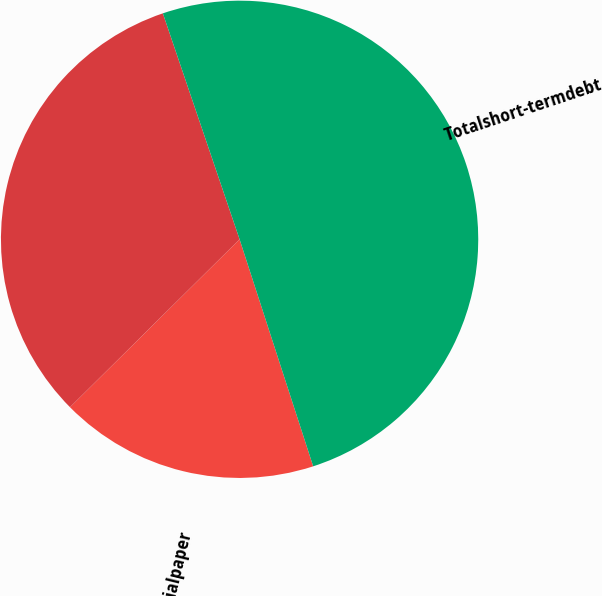<chart> <loc_0><loc_0><loc_500><loc_500><pie_chart><fcel>Commercialpaper<fcel>Unnamed: 1<fcel>Totalshort-termdebt<nl><fcel>17.57%<fcel>32.21%<fcel>50.22%<nl></chart> 